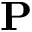Convert formula to latex. <formula><loc_0><loc_0><loc_500><loc_500>P</formula> 